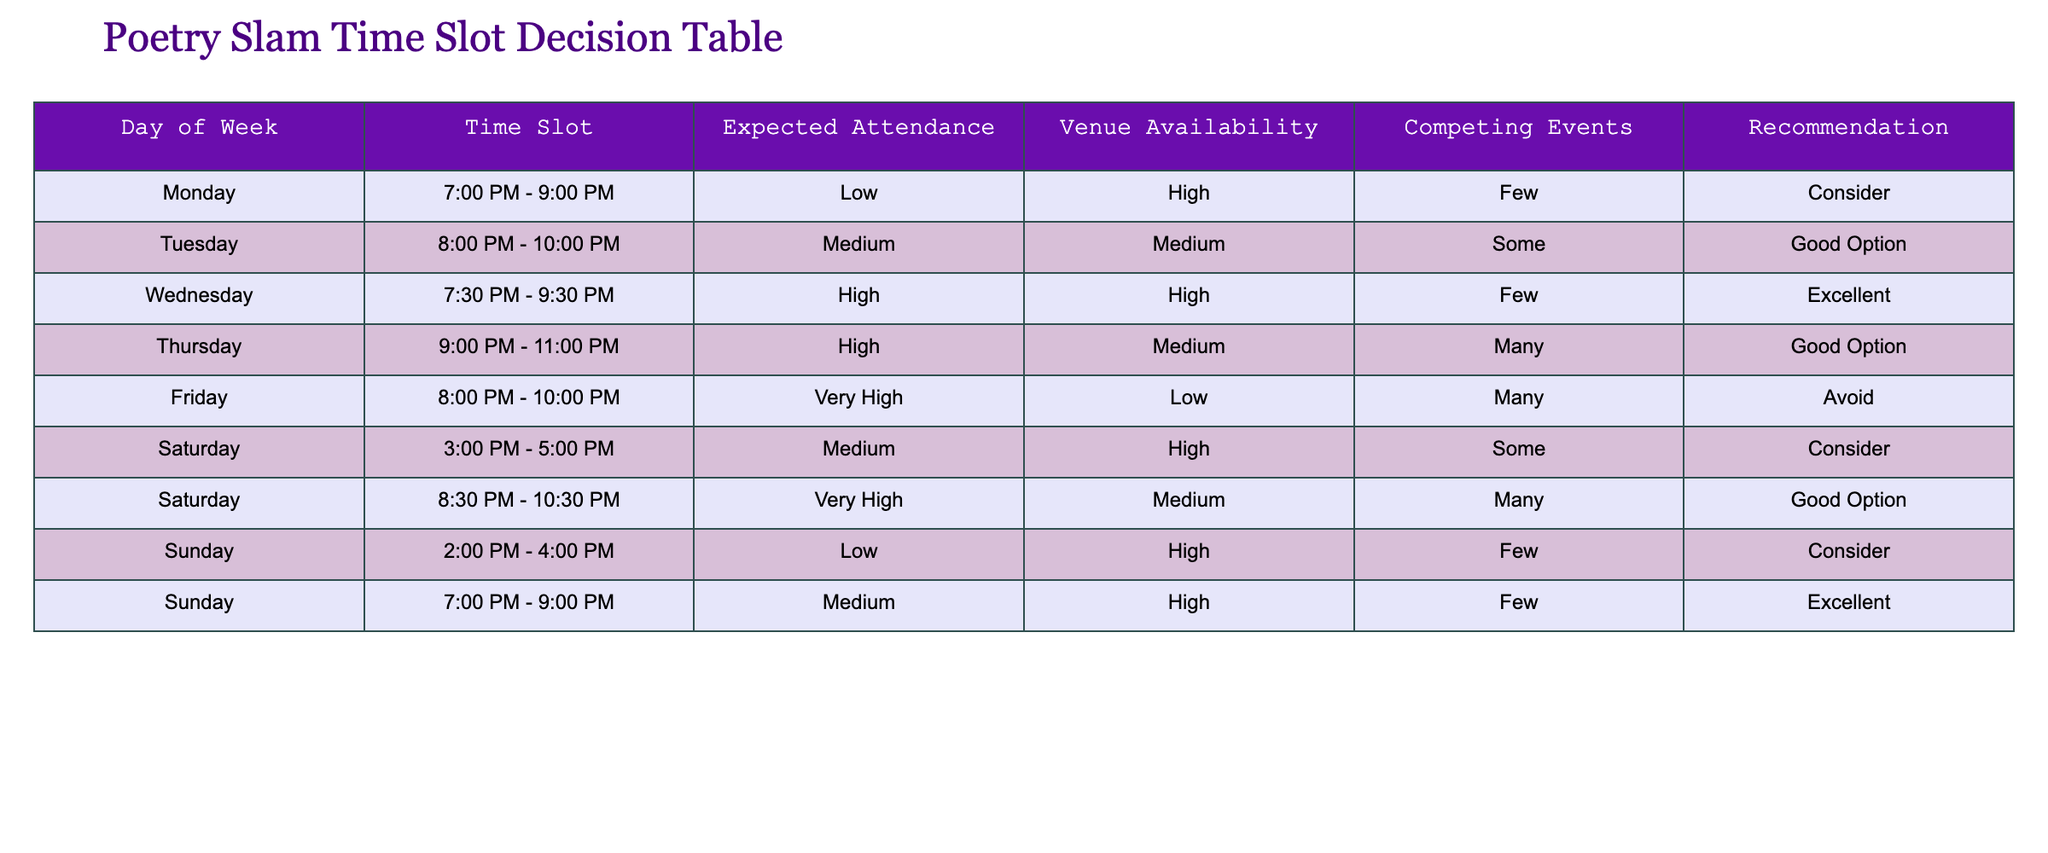What is the expected attendance for the poetry slam on Wednesday? The table shows the expected attendance for each day. Looking at the row for Wednesday, the value under Expected Attendance is "High."
Answer: High Which time slot has the highest expected attendance? By looking at the Expected Attendance column, the highest value listed is "Very High," which occurs for the time slots on Friday (8:00 PM - 10:00 PM) and Saturday (8:30 PM - 10:30 PM). Therefore, both are noted as having the highest expected attendance.
Answer: Friday and Saturday Are there any days with competing events that are marked as a 'Good Option'? We can check the Competing Events column for days marked as 'Good Option' in the Recommendation column. Both Tuesday and Thursday fall into this category.
Answer: Yes What is the average expected attendance for Saturday time slots? First, we need to identify the expected attendance values for Saturday. There are two rows: 3:00 PM - 5:00 PM has "Medium," and 8:30 PM - 10:30 PM has "Very High." We can translate these into numerical values: Low (1), Medium (2), High (3), Very High (4). Therefore, the average attendance is (2 + 4)/2 = 3, mapping back to between Medium and High.
Answer: Medium to High Is there a time slot on Sunday that has excellent recommendations? Checking the Recommendation column for Sunday, the 7:00 PM - 9:00 PM time slot is noted as "Excellent," indicating it is highly recommended.
Answer: Yes Which day of the week has the lowest expected attendance? The table contains expected attendance values for each day. Both Monday and Sunday (2:00 PM - 4:00 PM) have "Low." So, either could be considered the lowest.
Answer: Monday and Sunday What is the difference in the number of recommended options between Monday and Thursday? For Monday, the recommendation is "Consider," while for Thursday, it's "Good Option." This indicates one recommendation type for Monday and one for Thursday. Hence, the difference is zero; both have one recommendation type each.
Answer: Zero For which time slot should we avoid hosting the poetry slam? The table indicates that hosting the poetry slam on Friday from 8:00 PM to 10:00 PM is marked as "Avoid." This time slot should not be chosen when organizing the event.
Answer: Friday 8:00 PM - 10:00 PM 